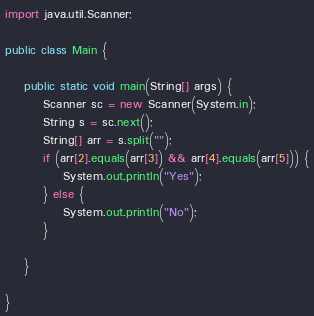<code> <loc_0><loc_0><loc_500><loc_500><_Java_>import java.util.Scanner;

public class Main {

	public static void main(String[] args) {
		Scanner sc = new Scanner(System.in);
		String s = sc.next();
		String[] arr = s.split("");
		if (arr[2].equals(arr[3]) && arr[4].equals(arr[5])) {
			System.out.println("Yes");
		} else {
			System.out.println("No");
		}

	}

}
</code> 